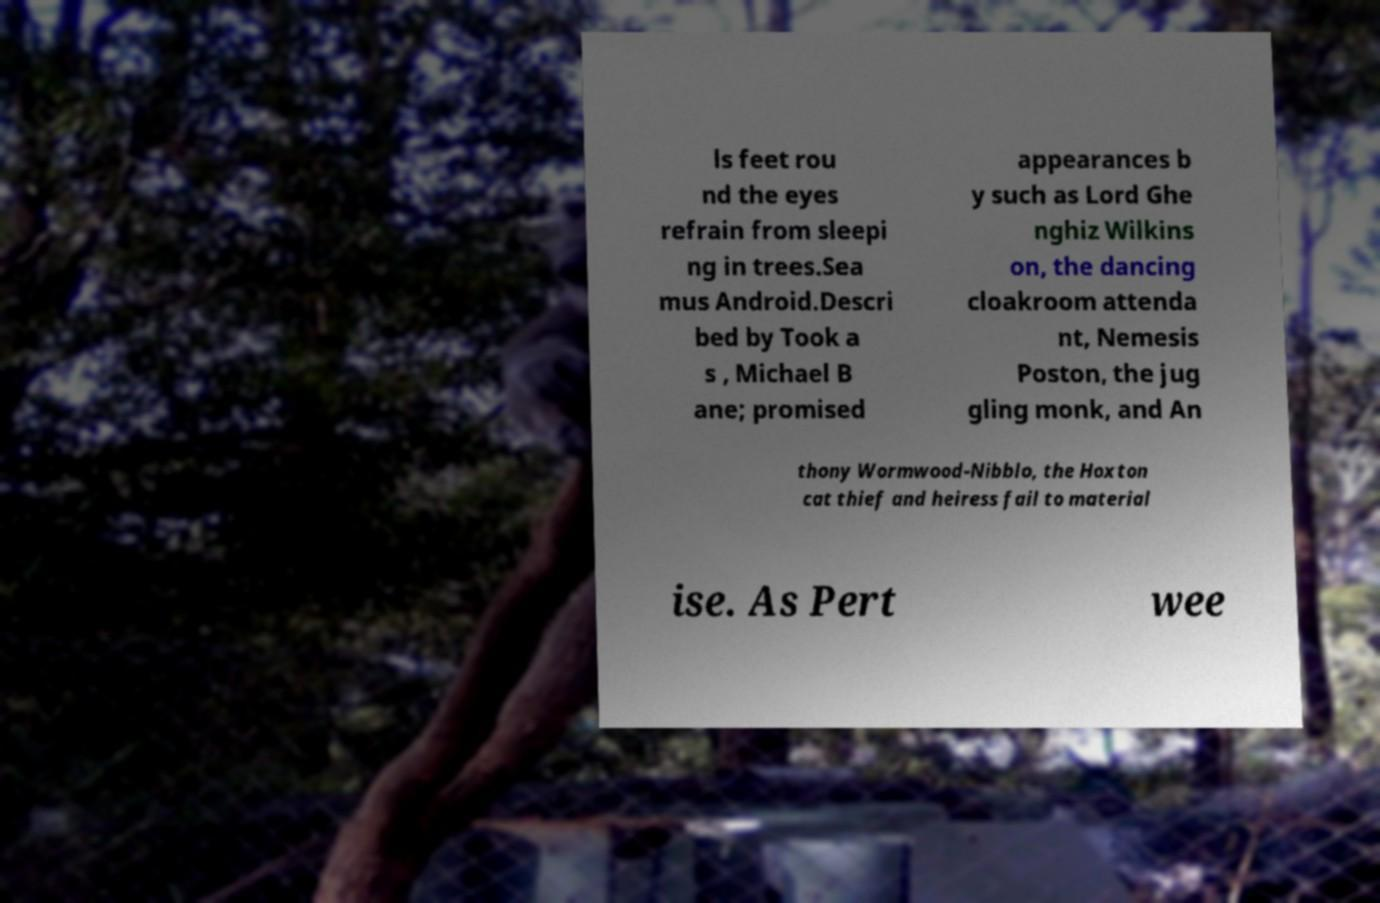Could you assist in decoding the text presented in this image and type it out clearly? ls feet rou nd the eyes refrain from sleepi ng in trees.Sea mus Android.Descri bed by Took a s , Michael B ane; promised appearances b y such as Lord Ghe nghiz Wilkins on, the dancing cloakroom attenda nt, Nemesis Poston, the jug gling monk, and An thony Wormwood-Nibblo, the Hoxton cat thief and heiress fail to material ise. As Pert wee 